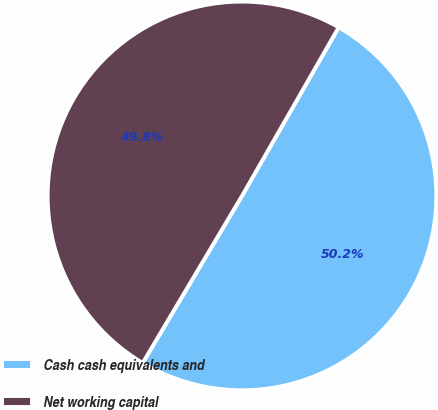Convert chart to OTSL. <chart><loc_0><loc_0><loc_500><loc_500><pie_chart><fcel>Cash cash equivalents and<fcel>Net working capital<nl><fcel>50.25%<fcel>49.75%<nl></chart> 